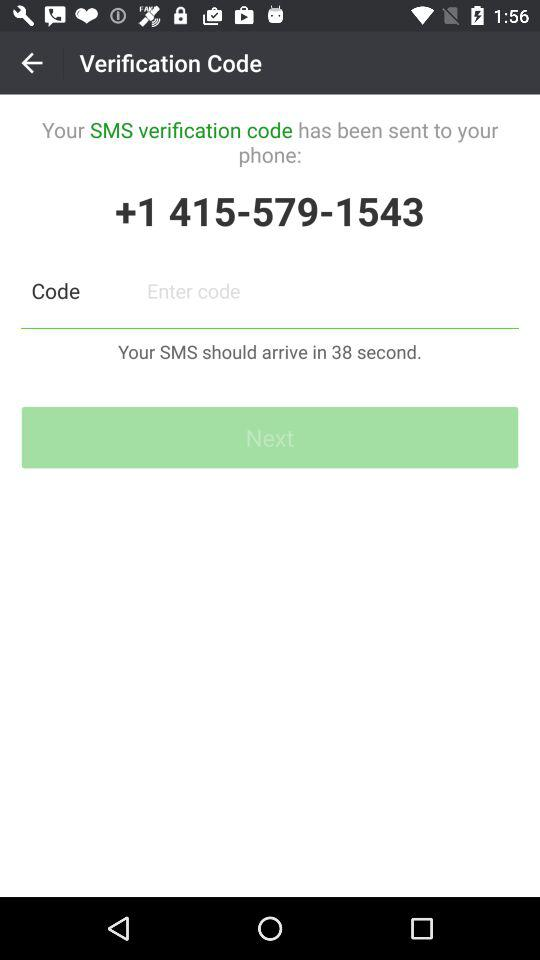What is the phone number that the SMS was sent to?
Answer the question using a single word or phrase. +1 415-579-1543 